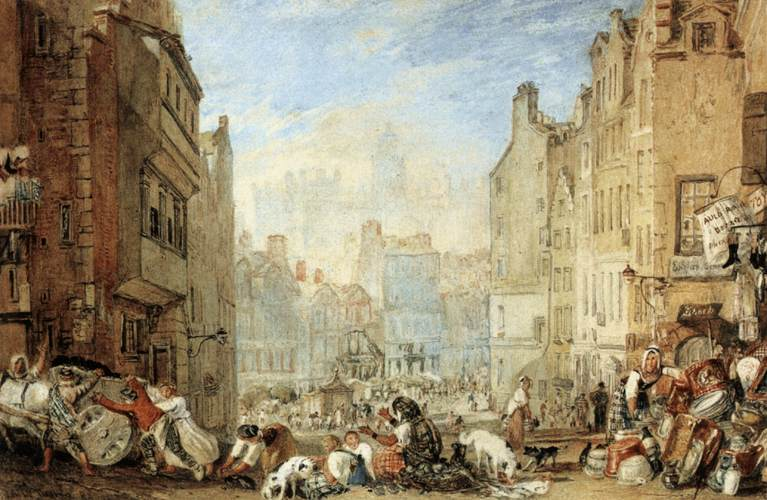Could you describe the activities people are engaged in within this scene? In the bustling street scene, various groups of people are depicted engaging in diverse activities common to a lively marketplace. Some individuals appear to be merchants, sitting beside their goods, which range from food items to textiles. Others are gathered in small groups, likely bartering or negotiating prices. Children are seen playing near adults, which contributes to a casual, community-focused atmosphere. On the edges, you can notice people carrying baskets, possibly indicating they are busy shopping or trading. 